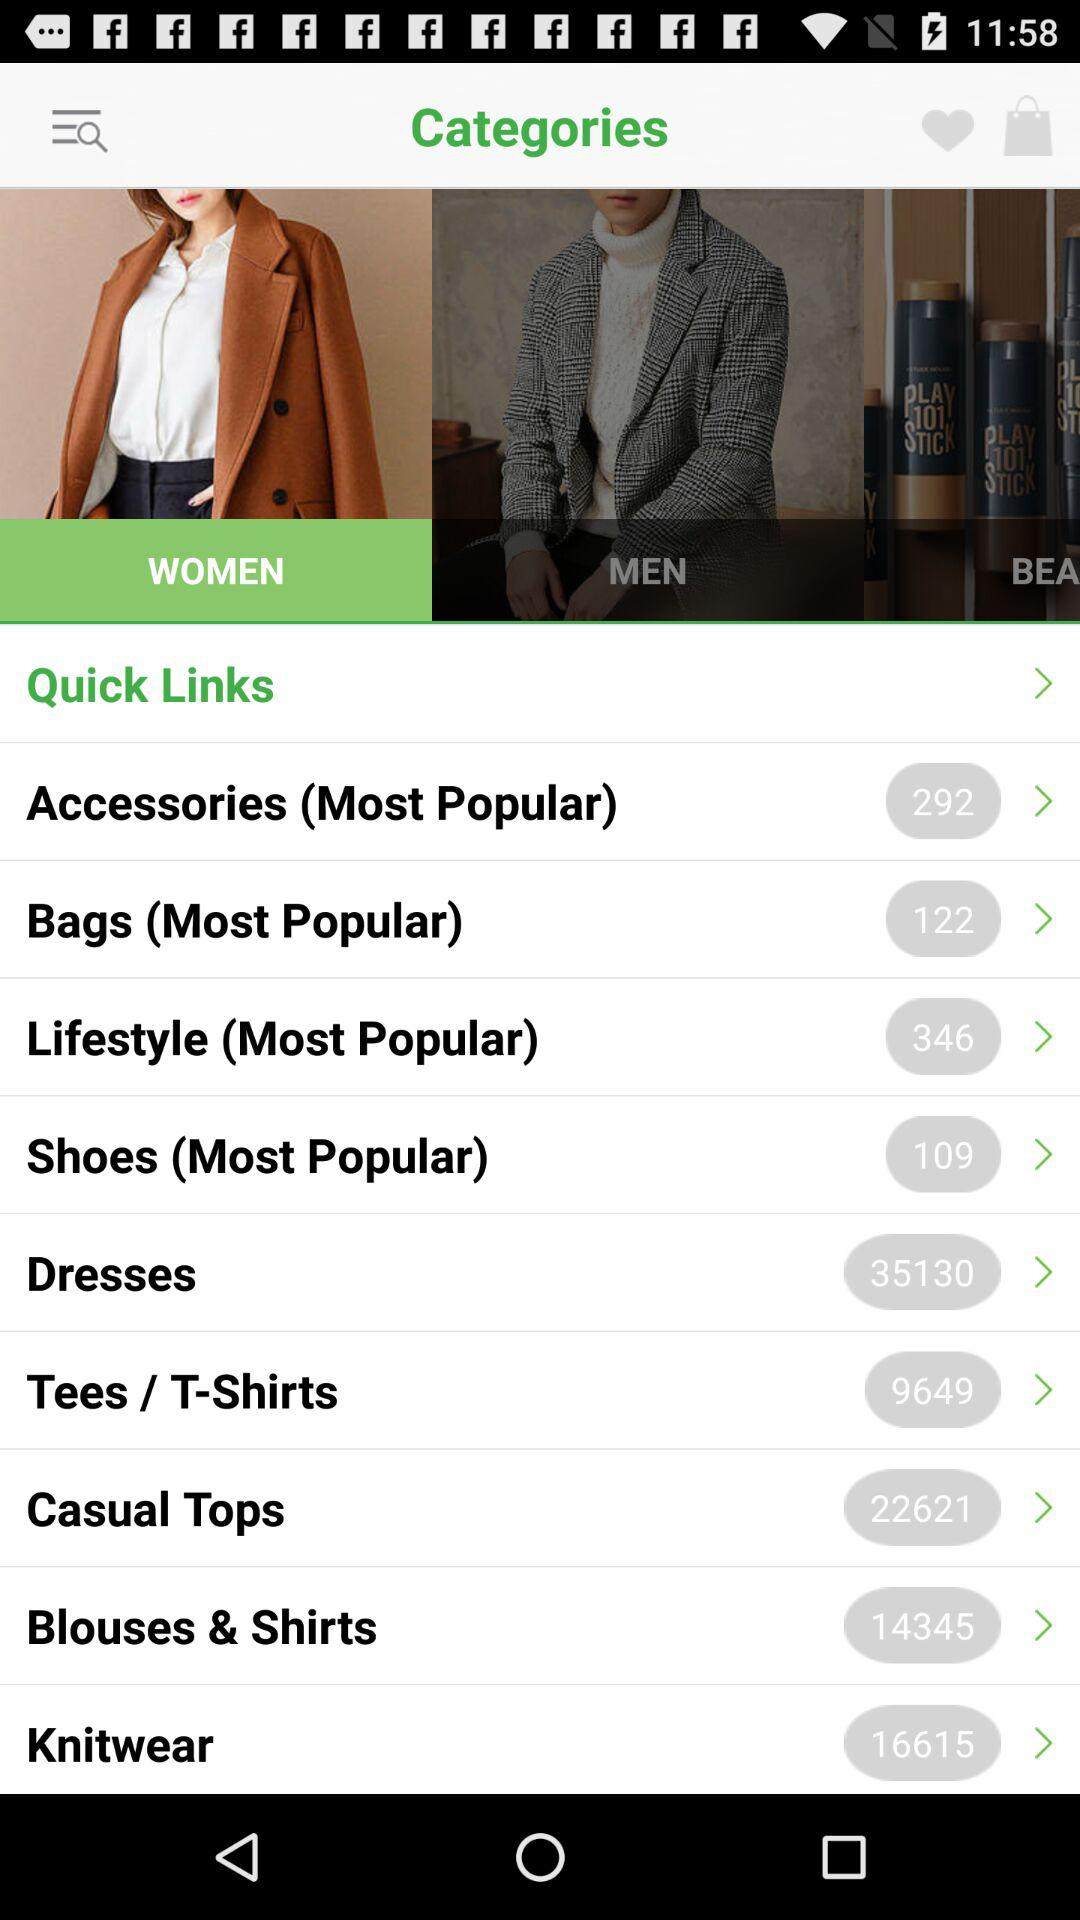What is the count of products in the "Lifestyle" category? The count of products is 346. 